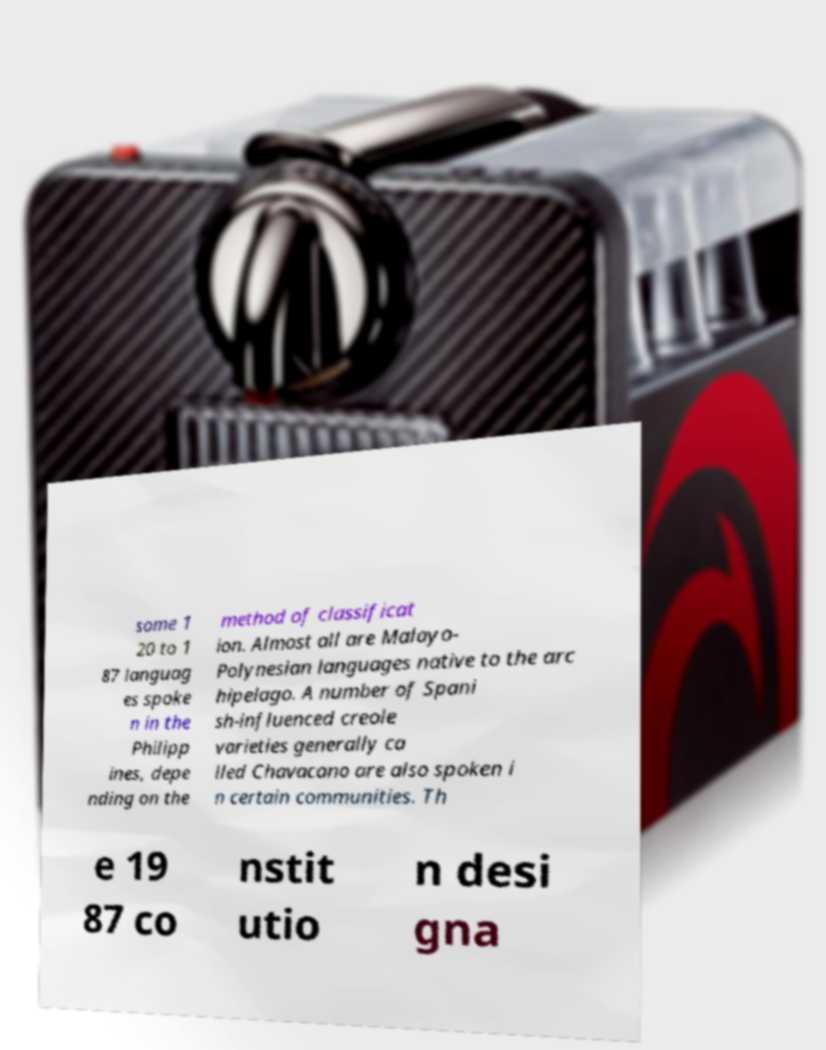Can you read and provide the text displayed in the image?This photo seems to have some interesting text. Can you extract and type it out for me? some 1 20 to 1 87 languag es spoke n in the Philipp ines, depe nding on the method of classificat ion. Almost all are Malayo- Polynesian languages native to the arc hipelago. A number of Spani sh-influenced creole varieties generally ca lled Chavacano are also spoken i n certain communities. Th e 19 87 co nstit utio n desi gna 